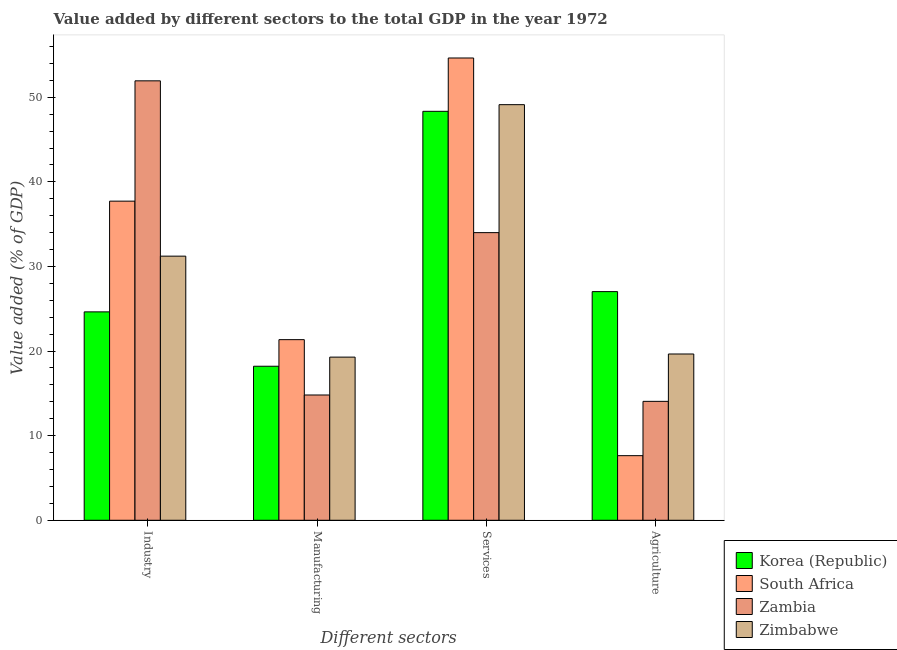How many groups of bars are there?
Your response must be concise. 4. Are the number of bars per tick equal to the number of legend labels?
Give a very brief answer. Yes. How many bars are there on the 4th tick from the left?
Provide a short and direct response. 4. What is the label of the 1st group of bars from the left?
Your answer should be very brief. Industry. What is the value added by agricultural sector in Zambia?
Your answer should be very brief. 14.06. Across all countries, what is the maximum value added by services sector?
Provide a succinct answer. 54.64. Across all countries, what is the minimum value added by manufacturing sector?
Give a very brief answer. 14.81. In which country was the value added by agricultural sector maximum?
Provide a succinct answer. Korea (Republic). In which country was the value added by agricultural sector minimum?
Ensure brevity in your answer.  South Africa. What is the total value added by agricultural sector in the graph?
Your answer should be very brief. 68.37. What is the difference between the value added by services sector in Korea (Republic) and that in Zambia?
Ensure brevity in your answer.  14.34. What is the difference between the value added by industrial sector in Zambia and the value added by agricultural sector in South Africa?
Make the answer very short. 44.31. What is the average value added by services sector per country?
Give a very brief answer. 46.53. What is the difference between the value added by agricultural sector and value added by industrial sector in Zimbabwe?
Offer a terse response. -11.57. What is the ratio of the value added by industrial sector in Zimbabwe to that in South Africa?
Ensure brevity in your answer.  0.83. Is the value added by agricultural sector in Korea (Republic) less than that in Zimbabwe?
Provide a succinct answer. No. What is the difference between the highest and the second highest value added by services sector?
Provide a short and direct response. 5.52. What is the difference between the highest and the lowest value added by manufacturing sector?
Your answer should be very brief. 6.54. Is the sum of the value added by agricultural sector in Zambia and Korea (Republic) greater than the maximum value added by manufacturing sector across all countries?
Offer a terse response. Yes. Is it the case that in every country, the sum of the value added by industrial sector and value added by services sector is greater than the sum of value added by manufacturing sector and value added by agricultural sector?
Your response must be concise. Yes. What does the 3rd bar from the left in Manufacturing represents?
Your answer should be compact. Zambia. What does the 1st bar from the right in Manufacturing represents?
Your answer should be very brief. Zimbabwe. Is it the case that in every country, the sum of the value added by industrial sector and value added by manufacturing sector is greater than the value added by services sector?
Offer a very short reply. No. How many countries are there in the graph?
Ensure brevity in your answer.  4. Does the graph contain grids?
Provide a short and direct response. No. Where does the legend appear in the graph?
Give a very brief answer. Bottom right. How many legend labels are there?
Provide a short and direct response. 4. What is the title of the graph?
Your response must be concise. Value added by different sectors to the total GDP in the year 1972. What is the label or title of the X-axis?
Offer a very short reply. Different sectors. What is the label or title of the Y-axis?
Provide a short and direct response. Value added (% of GDP). What is the Value added (% of GDP) in Korea (Republic) in Industry?
Make the answer very short. 24.63. What is the Value added (% of GDP) of South Africa in Industry?
Provide a succinct answer. 37.72. What is the Value added (% of GDP) of Zambia in Industry?
Your response must be concise. 51.94. What is the Value added (% of GDP) of Zimbabwe in Industry?
Make the answer very short. 31.22. What is the Value added (% of GDP) of Korea (Republic) in Manufacturing?
Provide a succinct answer. 18.21. What is the Value added (% of GDP) of South Africa in Manufacturing?
Provide a succinct answer. 21.35. What is the Value added (% of GDP) in Zambia in Manufacturing?
Offer a very short reply. 14.81. What is the Value added (% of GDP) of Zimbabwe in Manufacturing?
Ensure brevity in your answer.  19.29. What is the Value added (% of GDP) in Korea (Republic) in Services?
Provide a succinct answer. 48.34. What is the Value added (% of GDP) in South Africa in Services?
Your answer should be compact. 54.64. What is the Value added (% of GDP) of Zambia in Services?
Offer a terse response. 34. What is the Value added (% of GDP) of Zimbabwe in Services?
Make the answer very short. 49.13. What is the Value added (% of GDP) of Korea (Republic) in Agriculture?
Your answer should be compact. 27.03. What is the Value added (% of GDP) of South Africa in Agriculture?
Keep it short and to the point. 7.64. What is the Value added (% of GDP) of Zambia in Agriculture?
Keep it short and to the point. 14.06. What is the Value added (% of GDP) of Zimbabwe in Agriculture?
Keep it short and to the point. 19.65. Across all Different sectors, what is the maximum Value added (% of GDP) in Korea (Republic)?
Make the answer very short. 48.34. Across all Different sectors, what is the maximum Value added (% of GDP) in South Africa?
Your response must be concise. 54.64. Across all Different sectors, what is the maximum Value added (% of GDP) in Zambia?
Your answer should be very brief. 51.94. Across all Different sectors, what is the maximum Value added (% of GDP) of Zimbabwe?
Keep it short and to the point. 49.13. Across all Different sectors, what is the minimum Value added (% of GDP) of Korea (Republic)?
Make the answer very short. 18.21. Across all Different sectors, what is the minimum Value added (% of GDP) of South Africa?
Offer a very short reply. 7.64. Across all Different sectors, what is the minimum Value added (% of GDP) of Zambia?
Your answer should be compact. 14.06. Across all Different sectors, what is the minimum Value added (% of GDP) of Zimbabwe?
Your answer should be very brief. 19.29. What is the total Value added (% of GDP) of Korea (Republic) in the graph?
Give a very brief answer. 118.21. What is the total Value added (% of GDP) in South Africa in the graph?
Provide a short and direct response. 121.35. What is the total Value added (% of GDP) in Zambia in the graph?
Offer a terse response. 114.81. What is the total Value added (% of GDP) of Zimbabwe in the graph?
Ensure brevity in your answer.  119.29. What is the difference between the Value added (% of GDP) of Korea (Republic) in Industry and that in Manufacturing?
Your response must be concise. 6.43. What is the difference between the Value added (% of GDP) in South Africa in Industry and that in Manufacturing?
Make the answer very short. 16.37. What is the difference between the Value added (% of GDP) in Zambia in Industry and that in Manufacturing?
Your answer should be very brief. 37.13. What is the difference between the Value added (% of GDP) in Zimbabwe in Industry and that in Manufacturing?
Offer a very short reply. 11.93. What is the difference between the Value added (% of GDP) in Korea (Republic) in Industry and that in Services?
Give a very brief answer. -23.71. What is the difference between the Value added (% of GDP) in South Africa in Industry and that in Services?
Give a very brief answer. -16.92. What is the difference between the Value added (% of GDP) of Zambia in Industry and that in Services?
Your answer should be very brief. 17.94. What is the difference between the Value added (% of GDP) in Zimbabwe in Industry and that in Services?
Make the answer very short. -17.91. What is the difference between the Value added (% of GDP) in Korea (Republic) in Industry and that in Agriculture?
Your answer should be compact. -2.39. What is the difference between the Value added (% of GDP) of South Africa in Industry and that in Agriculture?
Your answer should be compact. 30.08. What is the difference between the Value added (% of GDP) of Zambia in Industry and that in Agriculture?
Give a very brief answer. 37.89. What is the difference between the Value added (% of GDP) in Zimbabwe in Industry and that in Agriculture?
Give a very brief answer. 11.57. What is the difference between the Value added (% of GDP) of Korea (Republic) in Manufacturing and that in Services?
Offer a very short reply. -30.13. What is the difference between the Value added (% of GDP) in South Africa in Manufacturing and that in Services?
Your answer should be very brief. -33.29. What is the difference between the Value added (% of GDP) of Zambia in Manufacturing and that in Services?
Give a very brief answer. -19.19. What is the difference between the Value added (% of GDP) of Zimbabwe in Manufacturing and that in Services?
Offer a very short reply. -29.84. What is the difference between the Value added (% of GDP) in Korea (Republic) in Manufacturing and that in Agriculture?
Ensure brevity in your answer.  -8.82. What is the difference between the Value added (% of GDP) of South Africa in Manufacturing and that in Agriculture?
Your answer should be compact. 13.71. What is the difference between the Value added (% of GDP) in Zambia in Manufacturing and that in Agriculture?
Make the answer very short. 0.75. What is the difference between the Value added (% of GDP) of Zimbabwe in Manufacturing and that in Agriculture?
Your answer should be compact. -0.37. What is the difference between the Value added (% of GDP) of Korea (Republic) in Services and that in Agriculture?
Give a very brief answer. 21.31. What is the difference between the Value added (% of GDP) of South Africa in Services and that in Agriculture?
Offer a very short reply. 47.01. What is the difference between the Value added (% of GDP) of Zambia in Services and that in Agriculture?
Ensure brevity in your answer.  19.94. What is the difference between the Value added (% of GDP) of Zimbabwe in Services and that in Agriculture?
Give a very brief answer. 29.47. What is the difference between the Value added (% of GDP) of Korea (Republic) in Industry and the Value added (% of GDP) of South Africa in Manufacturing?
Your response must be concise. 3.28. What is the difference between the Value added (% of GDP) in Korea (Republic) in Industry and the Value added (% of GDP) in Zambia in Manufacturing?
Provide a succinct answer. 9.82. What is the difference between the Value added (% of GDP) of Korea (Republic) in Industry and the Value added (% of GDP) of Zimbabwe in Manufacturing?
Give a very brief answer. 5.35. What is the difference between the Value added (% of GDP) in South Africa in Industry and the Value added (% of GDP) in Zambia in Manufacturing?
Give a very brief answer. 22.91. What is the difference between the Value added (% of GDP) of South Africa in Industry and the Value added (% of GDP) of Zimbabwe in Manufacturing?
Your answer should be very brief. 18.44. What is the difference between the Value added (% of GDP) of Zambia in Industry and the Value added (% of GDP) of Zimbabwe in Manufacturing?
Provide a succinct answer. 32.66. What is the difference between the Value added (% of GDP) in Korea (Republic) in Industry and the Value added (% of GDP) in South Africa in Services?
Offer a very short reply. -30.01. What is the difference between the Value added (% of GDP) of Korea (Republic) in Industry and the Value added (% of GDP) of Zambia in Services?
Provide a short and direct response. -9.37. What is the difference between the Value added (% of GDP) in Korea (Republic) in Industry and the Value added (% of GDP) in Zimbabwe in Services?
Your answer should be compact. -24.49. What is the difference between the Value added (% of GDP) in South Africa in Industry and the Value added (% of GDP) in Zambia in Services?
Give a very brief answer. 3.72. What is the difference between the Value added (% of GDP) in South Africa in Industry and the Value added (% of GDP) in Zimbabwe in Services?
Offer a very short reply. -11.41. What is the difference between the Value added (% of GDP) in Zambia in Industry and the Value added (% of GDP) in Zimbabwe in Services?
Keep it short and to the point. 2.82. What is the difference between the Value added (% of GDP) in Korea (Republic) in Industry and the Value added (% of GDP) in South Africa in Agriculture?
Your answer should be very brief. 17. What is the difference between the Value added (% of GDP) of Korea (Republic) in Industry and the Value added (% of GDP) of Zambia in Agriculture?
Offer a very short reply. 10.58. What is the difference between the Value added (% of GDP) in Korea (Republic) in Industry and the Value added (% of GDP) in Zimbabwe in Agriculture?
Provide a succinct answer. 4.98. What is the difference between the Value added (% of GDP) in South Africa in Industry and the Value added (% of GDP) in Zambia in Agriculture?
Provide a succinct answer. 23.66. What is the difference between the Value added (% of GDP) in South Africa in Industry and the Value added (% of GDP) in Zimbabwe in Agriculture?
Offer a terse response. 18.07. What is the difference between the Value added (% of GDP) of Zambia in Industry and the Value added (% of GDP) of Zimbabwe in Agriculture?
Provide a succinct answer. 32.29. What is the difference between the Value added (% of GDP) of Korea (Republic) in Manufacturing and the Value added (% of GDP) of South Africa in Services?
Provide a succinct answer. -36.44. What is the difference between the Value added (% of GDP) in Korea (Republic) in Manufacturing and the Value added (% of GDP) in Zambia in Services?
Your answer should be compact. -15.79. What is the difference between the Value added (% of GDP) in Korea (Republic) in Manufacturing and the Value added (% of GDP) in Zimbabwe in Services?
Give a very brief answer. -30.92. What is the difference between the Value added (% of GDP) of South Africa in Manufacturing and the Value added (% of GDP) of Zambia in Services?
Ensure brevity in your answer.  -12.65. What is the difference between the Value added (% of GDP) in South Africa in Manufacturing and the Value added (% of GDP) in Zimbabwe in Services?
Provide a succinct answer. -27.78. What is the difference between the Value added (% of GDP) in Zambia in Manufacturing and the Value added (% of GDP) in Zimbabwe in Services?
Give a very brief answer. -34.32. What is the difference between the Value added (% of GDP) of Korea (Republic) in Manufacturing and the Value added (% of GDP) of South Africa in Agriculture?
Your answer should be compact. 10.57. What is the difference between the Value added (% of GDP) of Korea (Republic) in Manufacturing and the Value added (% of GDP) of Zambia in Agriculture?
Offer a very short reply. 4.15. What is the difference between the Value added (% of GDP) of Korea (Republic) in Manufacturing and the Value added (% of GDP) of Zimbabwe in Agriculture?
Your answer should be very brief. -1.45. What is the difference between the Value added (% of GDP) in South Africa in Manufacturing and the Value added (% of GDP) in Zambia in Agriculture?
Your response must be concise. 7.29. What is the difference between the Value added (% of GDP) of South Africa in Manufacturing and the Value added (% of GDP) of Zimbabwe in Agriculture?
Make the answer very short. 1.7. What is the difference between the Value added (% of GDP) in Zambia in Manufacturing and the Value added (% of GDP) in Zimbabwe in Agriculture?
Ensure brevity in your answer.  -4.85. What is the difference between the Value added (% of GDP) of Korea (Republic) in Services and the Value added (% of GDP) of South Africa in Agriculture?
Give a very brief answer. 40.7. What is the difference between the Value added (% of GDP) in Korea (Republic) in Services and the Value added (% of GDP) in Zambia in Agriculture?
Provide a succinct answer. 34.28. What is the difference between the Value added (% of GDP) in Korea (Republic) in Services and the Value added (% of GDP) in Zimbabwe in Agriculture?
Your answer should be very brief. 28.69. What is the difference between the Value added (% of GDP) in South Africa in Services and the Value added (% of GDP) in Zambia in Agriculture?
Give a very brief answer. 40.59. What is the difference between the Value added (% of GDP) in South Africa in Services and the Value added (% of GDP) in Zimbabwe in Agriculture?
Your response must be concise. 34.99. What is the difference between the Value added (% of GDP) of Zambia in Services and the Value added (% of GDP) of Zimbabwe in Agriculture?
Offer a terse response. 14.35. What is the average Value added (% of GDP) in Korea (Republic) per Different sectors?
Your answer should be compact. 29.55. What is the average Value added (% of GDP) in South Africa per Different sectors?
Your answer should be very brief. 30.34. What is the average Value added (% of GDP) in Zambia per Different sectors?
Provide a short and direct response. 28.7. What is the average Value added (% of GDP) in Zimbabwe per Different sectors?
Your answer should be very brief. 29.82. What is the difference between the Value added (% of GDP) in Korea (Republic) and Value added (% of GDP) in South Africa in Industry?
Offer a very short reply. -13.09. What is the difference between the Value added (% of GDP) in Korea (Republic) and Value added (% of GDP) in Zambia in Industry?
Your answer should be compact. -27.31. What is the difference between the Value added (% of GDP) of Korea (Republic) and Value added (% of GDP) of Zimbabwe in Industry?
Keep it short and to the point. -6.59. What is the difference between the Value added (% of GDP) of South Africa and Value added (% of GDP) of Zambia in Industry?
Provide a succinct answer. -14.22. What is the difference between the Value added (% of GDP) of South Africa and Value added (% of GDP) of Zimbabwe in Industry?
Your answer should be compact. 6.5. What is the difference between the Value added (% of GDP) of Zambia and Value added (% of GDP) of Zimbabwe in Industry?
Ensure brevity in your answer.  20.72. What is the difference between the Value added (% of GDP) of Korea (Republic) and Value added (% of GDP) of South Africa in Manufacturing?
Offer a very short reply. -3.14. What is the difference between the Value added (% of GDP) in Korea (Republic) and Value added (% of GDP) in Zambia in Manufacturing?
Your answer should be very brief. 3.4. What is the difference between the Value added (% of GDP) of Korea (Republic) and Value added (% of GDP) of Zimbabwe in Manufacturing?
Keep it short and to the point. -1.08. What is the difference between the Value added (% of GDP) of South Africa and Value added (% of GDP) of Zambia in Manufacturing?
Give a very brief answer. 6.54. What is the difference between the Value added (% of GDP) in South Africa and Value added (% of GDP) in Zimbabwe in Manufacturing?
Your answer should be compact. 2.06. What is the difference between the Value added (% of GDP) in Zambia and Value added (% of GDP) in Zimbabwe in Manufacturing?
Your answer should be very brief. -4.48. What is the difference between the Value added (% of GDP) in Korea (Republic) and Value added (% of GDP) in South Africa in Services?
Keep it short and to the point. -6.3. What is the difference between the Value added (% of GDP) of Korea (Republic) and Value added (% of GDP) of Zambia in Services?
Make the answer very short. 14.34. What is the difference between the Value added (% of GDP) of Korea (Republic) and Value added (% of GDP) of Zimbabwe in Services?
Ensure brevity in your answer.  -0.79. What is the difference between the Value added (% of GDP) in South Africa and Value added (% of GDP) in Zambia in Services?
Provide a short and direct response. 20.64. What is the difference between the Value added (% of GDP) of South Africa and Value added (% of GDP) of Zimbabwe in Services?
Your answer should be very brief. 5.52. What is the difference between the Value added (% of GDP) of Zambia and Value added (% of GDP) of Zimbabwe in Services?
Provide a succinct answer. -15.13. What is the difference between the Value added (% of GDP) of Korea (Republic) and Value added (% of GDP) of South Africa in Agriculture?
Ensure brevity in your answer.  19.39. What is the difference between the Value added (% of GDP) of Korea (Republic) and Value added (% of GDP) of Zambia in Agriculture?
Offer a terse response. 12.97. What is the difference between the Value added (% of GDP) of Korea (Republic) and Value added (% of GDP) of Zimbabwe in Agriculture?
Provide a succinct answer. 7.37. What is the difference between the Value added (% of GDP) in South Africa and Value added (% of GDP) in Zambia in Agriculture?
Offer a very short reply. -6.42. What is the difference between the Value added (% of GDP) in South Africa and Value added (% of GDP) in Zimbabwe in Agriculture?
Offer a terse response. -12.02. What is the difference between the Value added (% of GDP) in Zambia and Value added (% of GDP) in Zimbabwe in Agriculture?
Offer a very short reply. -5.6. What is the ratio of the Value added (% of GDP) in Korea (Republic) in Industry to that in Manufacturing?
Keep it short and to the point. 1.35. What is the ratio of the Value added (% of GDP) of South Africa in Industry to that in Manufacturing?
Offer a terse response. 1.77. What is the ratio of the Value added (% of GDP) of Zambia in Industry to that in Manufacturing?
Offer a very short reply. 3.51. What is the ratio of the Value added (% of GDP) in Zimbabwe in Industry to that in Manufacturing?
Ensure brevity in your answer.  1.62. What is the ratio of the Value added (% of GDP) of Korea (Republic) in Industry to that in Services?
Offer a terse response. 0.51. What is the ratio of the Value added (% of GDP) in South Africa in Industry to that in Services?
Make the answer very short. 0.69. What is the ratio of the Value added (% of GDP) of Zambia in Industry to that in Services?
Ensure brevity in your answer.  1.53. What is the ratio of the Value added (% of GDP) of Zimbabwe in Industry to that in Services?
Keep it short and to the point. 0.64. What is the ratio of the Value added (% of GDP) in Korea (Republic) in Industry to that in Agriculture?
Keep it short and to the point. 0.91. What is the ratio of the Value added (% of GDP) of South Africa in Industry to that in Agriculture?
Ensure brevity in your answer.  4.94. What is the ratio of the Value added (% of GDP) of Zambia in Industry to that in Agriculture?
Provide a succinct answer. 3.7. What is the ratio of the Value added (% of GDP) in Zimbabwe in Industry to that in Agriculture?
Make the answer very short. 1.59. What is the ratio of the Value added (% of GDP) in Korea (Republic) in Manufacturing to that in Services?
Offer a terse response. 0.38. What is the ratio of the Value added (% of GDP) of South Africa in Manufacturing to that in Services?
Give a very brief answer. 0.39. What is the ratio of the Value added (% of GDP) in Zambia in Manufacturing to that in Services?
Provide a short and direct response. 0.44. What is the ratio of the Value added (% of GDP) in Zimbabwe in Manufacturing to that in Services?
Ensure brevity in your answer.  0.39. What is the ratio of the Value added (% of GDP) in Korea (Republic) in Manufacturing to that in Agriculture?
Provide a succinct answer. 0.67. What is the ratio of the Value added (% of GDP) in South Africa in Manufacturing to that in Agriculture?
Offer a very short reply. 2.8. What is the ratio of the Value added (% of GDP) of Zambia in Manufacturing to that in Agriculture?
Offer a very short reply. 1.05. What is the ratio of the Value added (% of GDP) in Zimbabwe in Manufacturing to that in Agriculture?
Your answer should be very brief. 0.98. What is the ratio of the Value added (% of GDP) in Korea (Republic) in Services to that in Agriculture?
Offer a very short reply. 1.79. What is the ratio of the Value added (% of GDP) of South Africa in Services to that in Agriculture?
Make the answer very short. 7.16. What is the ratio of the Value added (% of GDP) in Zambia in Services to that in Agriculture?
Your response must be concise. 2.42. What is the ratio of the Value added (% of GDP) in Zimbabwe in Services to that in Agriculture?
Offer a very short reply. 2.5. What is the difference between the highest and the second highest Value added (% of GDP) in Korea (Republic)?
Keep it short and to the point. 21.31. What is the difference between the highest and the second highest Value added (% of GDP) in South Africa?
Ensure brevity in your answer.  16.92. What is the difference between the highest and the second highest Value added (% of GDP) of Zambia?
Make the answer very short. 17.94. What is the difference between the highest and the second highest Value added (% of GDP) in Zimbabwe?
Give a very brief answer. 17.91. What is the difference between the highest and the lowest Value added (% of GDP) in Korea (Republic)?
Provide a succinct answer. 30.13. What is the difference between the highest and the lowest Value added (% of GDP) of South Africa?
Offer a terse response. 47.01. What is the difference between the highest and the lowest Value added (% of GDP) in Zambia?
Provide a succinct answer. 37.89. What is the difference between the highest and the lowest Value added (% of GDP) in Zimbabwe?
Make the answer very short. 29.84. 